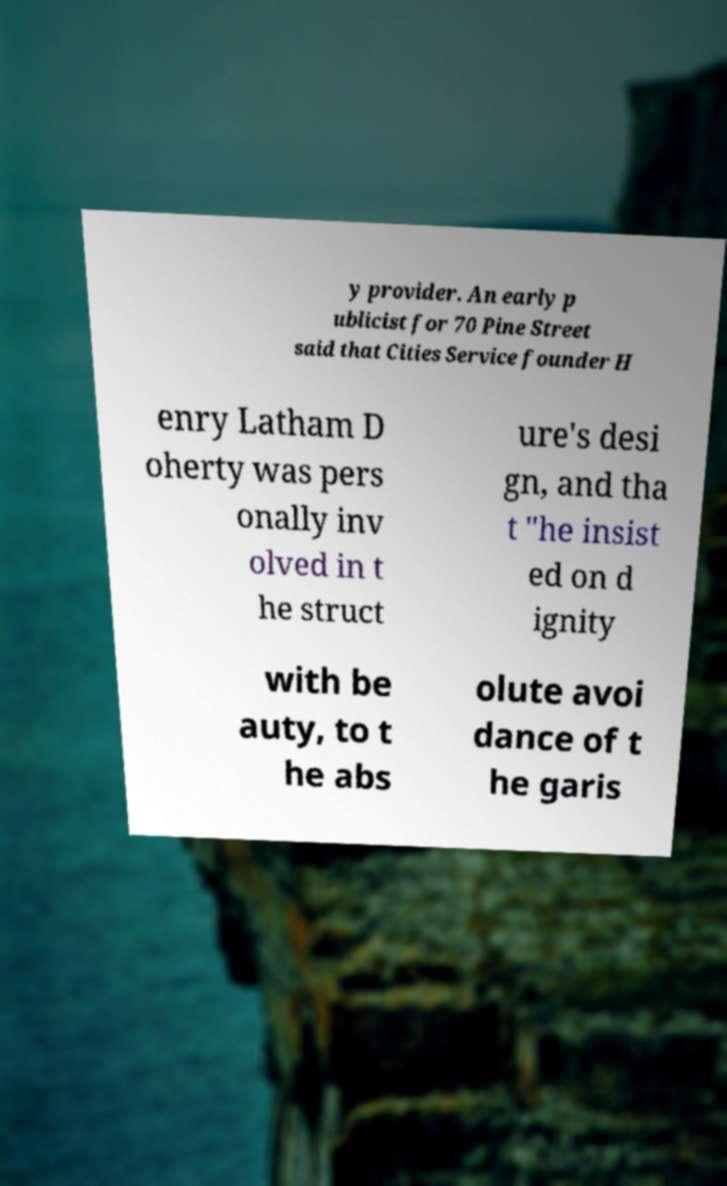Please read and relay the text visible in this image. What does it say? y provider. An early p ublicist for 70 Pine Street said that Cities Service founder H enry Latham D oherty was pers onally inv olved in t he struct ure's desi gn, and tha t "he insist ed on d ignity with be auty, to t he abs olute avoi dance of t he garis 